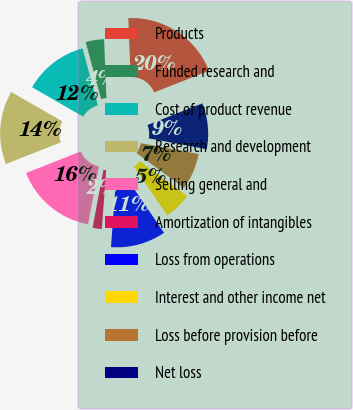<chart> <loc_0><loc_0><loc_500><loc_500><pie_chart><fcel>Products<fcel>Funded research and<fcel>Cost of product revenue<fcel>Research and development<fcel>Selling general and<fcel>Amortization of intangibles<fcel>Loss from operations<fcel>Interest and other income net<fcel>Loss before provision before<fcel>Net loss<nl><fcel>19.64%<fcel>3.57%<fcel>12.5%<fcel>14.29%<fcel>16.07%<fcel>1.79%<fcel>10.71%<fcel>5.36%<fcel>7.14%<fcel>8.93%<nl></chart> 